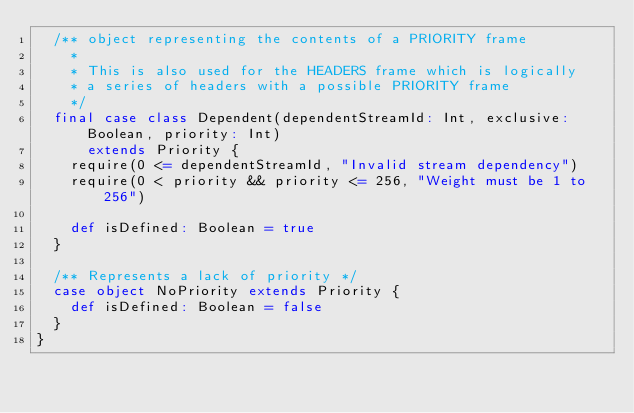<code> <loc_0><loc_0><loc_500><loc_500><_Scala_>  /** object representing the contents of a PRIORITY frame
    *
    * This is also used for the HEADERS frame which is logically
    * a series of headers with a possible PRIORITY frame
    */
  final case class Dependent(dependentStreamId: Int, exclusive: Boolean, priority: Int)
      extends Priority {
    require(0 <= dependentStreamId, "Invalid stream dependency")
    require(0 < priority && priority <= 256, "Weight must be 1 to 256")

    def isDefined: Boolean = true
  }

  /** Represents a lack of priority */
  case object NoPriority extends Priority {
    def isDefined: Boolean = false
  }
}
</code> 